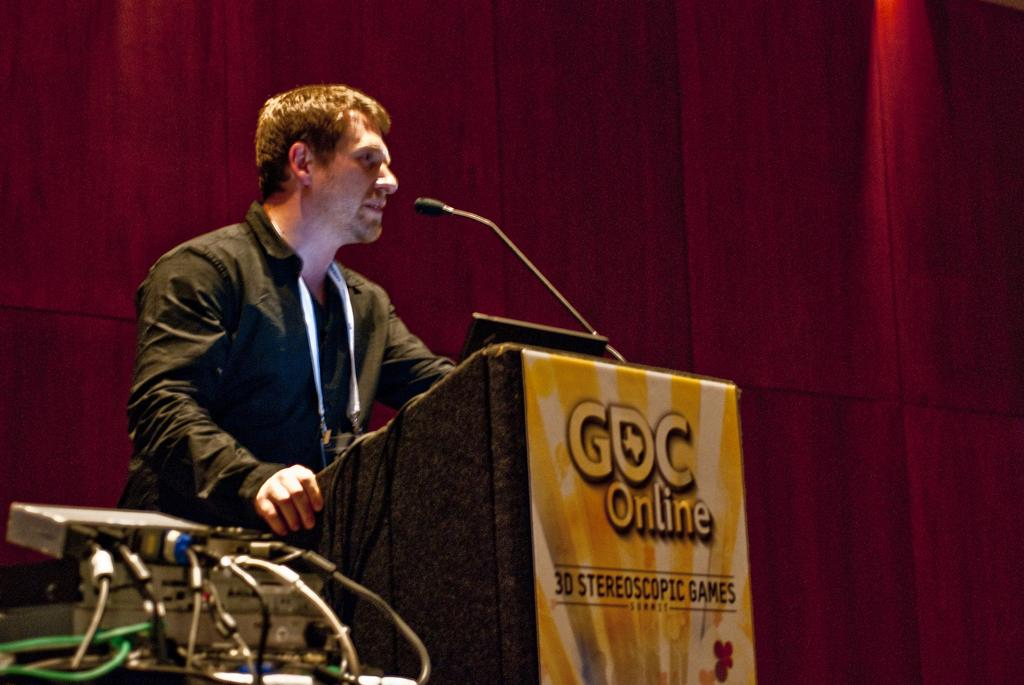<image>
Write a terse but informative summary of the picture. A speaker at a podium is talking about stereoscopic games. 